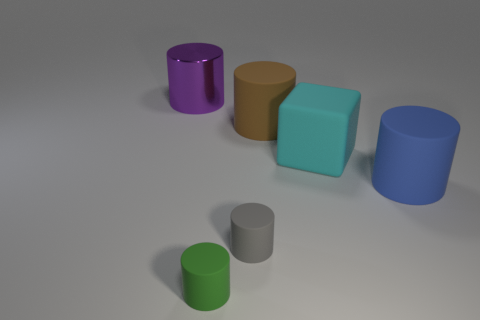Are there any other things that have the same shape as the large cyan rubber thing?
Your response must be concise. No. Does the large cylinder in front of the brown rubber cylinder have the same material as the purple cylinder behind the cyan matte object?
Offer a terse response. No. There is a object that is both left of the small gray rubber object and behind the blue rubber cylinder; what shape is it?
Provide a succinct answer. Cylinder. There is a cylinder that is right of the green cylinder and behind the rubber cube; what is its color?
Provide a short and direct response. Brown. Are there more rubber cylinders that are on the left side of the large metallic cylinder than brown matte cylinders behind the brown thing?
Keep it short and to the point. No. The rubber cylinder right of the cyan block is what color?
Your answer should be compact. Blue. There is a matte object that is on the left side of the small gray thing; does it have the same shape as the cyan thing that is right of the brown rubber cylinder?
Offer a terse response. No. Is there another blue metallic object of the same size as the blue object?
Offer a terse response. No. There is a big cylinder left of the small green rubber cylinder; what is its material?
Your answer should be compact. Metal. Do the large cylinder that is on the left side of the gray cylinder and the cyan thing have the same material?
Your answer should be compact. No. 